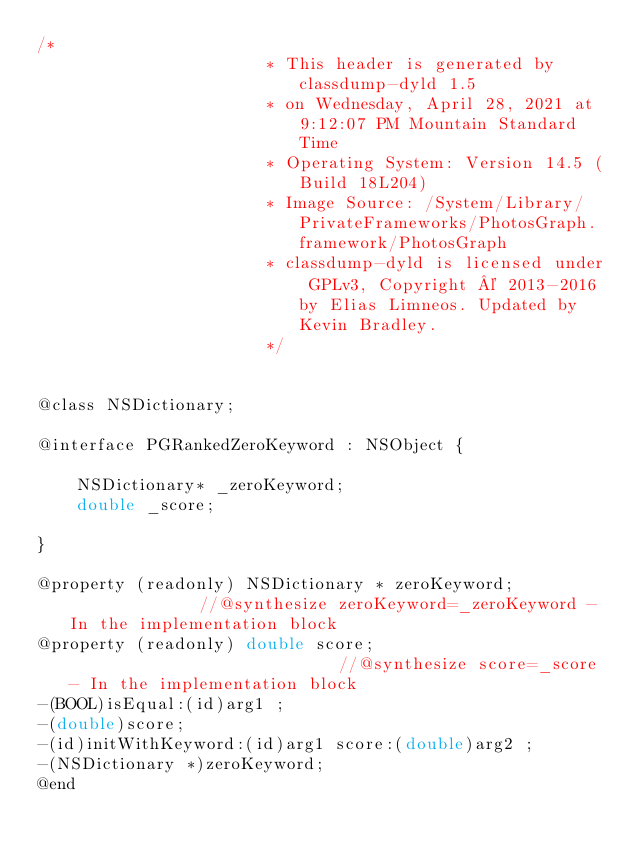Convert code to text. <code><loc_0><loc_0><loc_500><loc_500><_C_>/*
                       * This header is generated by classdump-dyld 1.5
                       * on Wednesday, April 28, 2021 at 9:12:07 PM Mountain Standard Time
                       * Operating System: Version 14.5 (Build 18L204)
                       * Image Source: /System/Library/PrivateFrameworks/PhotosGraph.framework/PhotosGraph
                       * classdump-dyld is licensed under GPLv3, Copyright © 2013-2016 by Elias Limneos. Updated by Kevin Bradley.
                       */


@class NSDictionary;

@interface PGRankedZeroKeyword : NSObject {

	NSDictionary* _zeroKeyword;
	double _score;

}

@property (readonly) NSDictionary * zeroKeyword;              //@synthesize zeroKeyword=_zeroKeyword - In the implementation block
@property (readonly) double score;                            //@synthesize score=_score - In the implementation block
-(BOOL)isEqual:(id)arg1 ;
-(double)score;
-(id)initWithKeyword:(id)arg1 score:(double)arg2 ;
-(NSDictionary *)zeroKeyword;
@end

</code> 